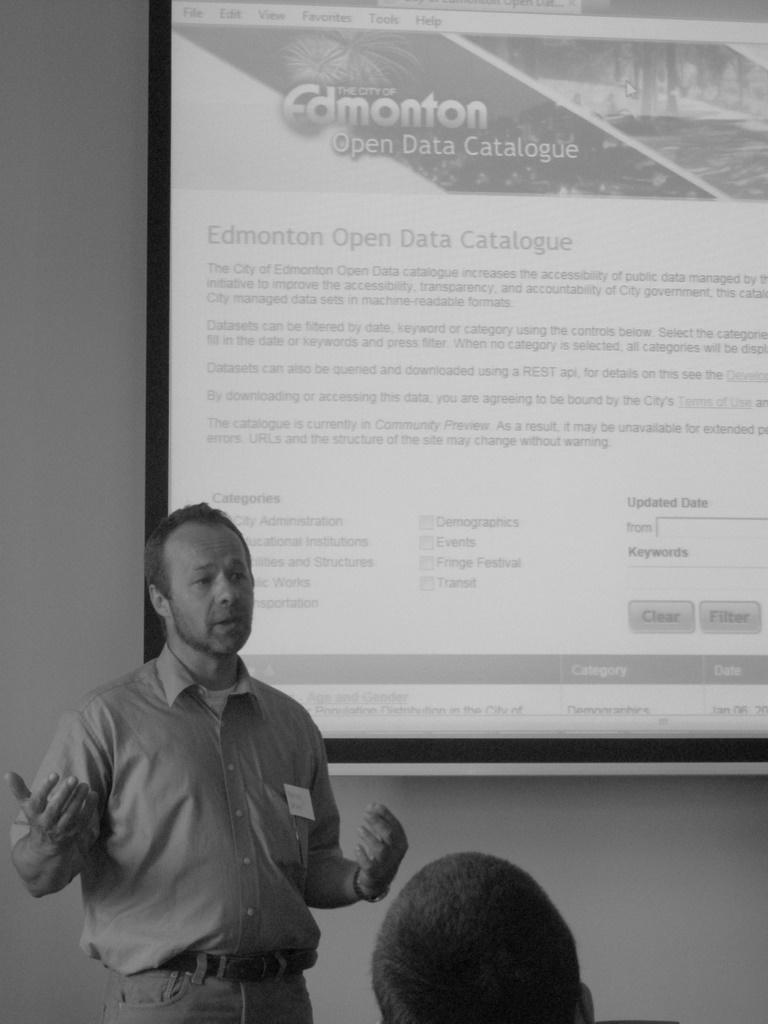In one or two sentences, can you explain what this image depicts? This is a black and white image. In the foreground of the picture there is a man saying something. In the center there is a person's head. In the background there is screen and a wall. 